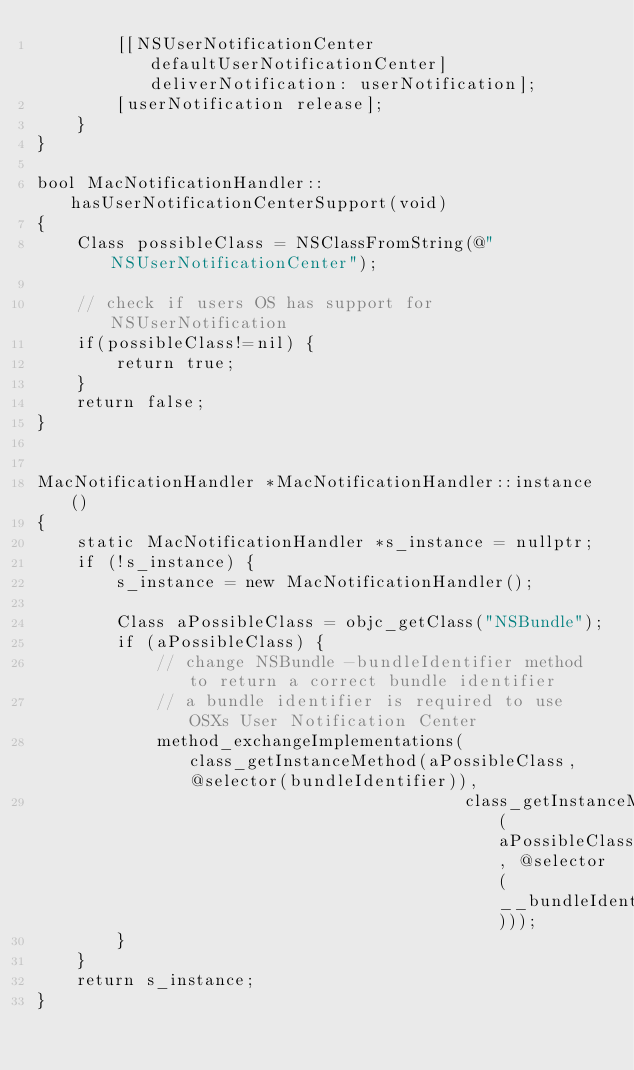<code> <loc_0><loc_0><loc_500><loc_500><_ObjectiveC_>        [[NSUserNotificationCenter defaultUserNotificationCenter] deliverNotification: userNotification];
        [userNotification release];
    }
}

bool MacNotificationHandler::hasUserNotificationCenterSupport(void)
{
    Class possibleClass = NSClassFromString(@"NSUserNotificationCenter");

    // check if users OS has support for NSUserNotification
    if(possibleClass!=nil) {
        return true;
    }
    return false;
}


MacNotificationHandler *MacNotificationHandler::instance()
{
    static MacNotificationHandler *s_instance = nullptr;
    if (!s_instance) {
        s_instance = new MacNotificationHandler();

        Class aPossibleClass = objc_getClass("NSBundle");
        if (aPossibleClass) {
            // change NSBundle -bundleIdentifier method to return a correct bundle identifier
            // a bundle identifier is required to use OSXs User Notification Center
            method_exchangeImplementations(class_getInstanceMethod(aPossibleClass, @selector(bundleIdentifier)),
                                           class_getInstanceMethod(aPossibleClass, @selector(__bundleIdentifier)));
        }
    }
    return s_instance;
}
</code> 